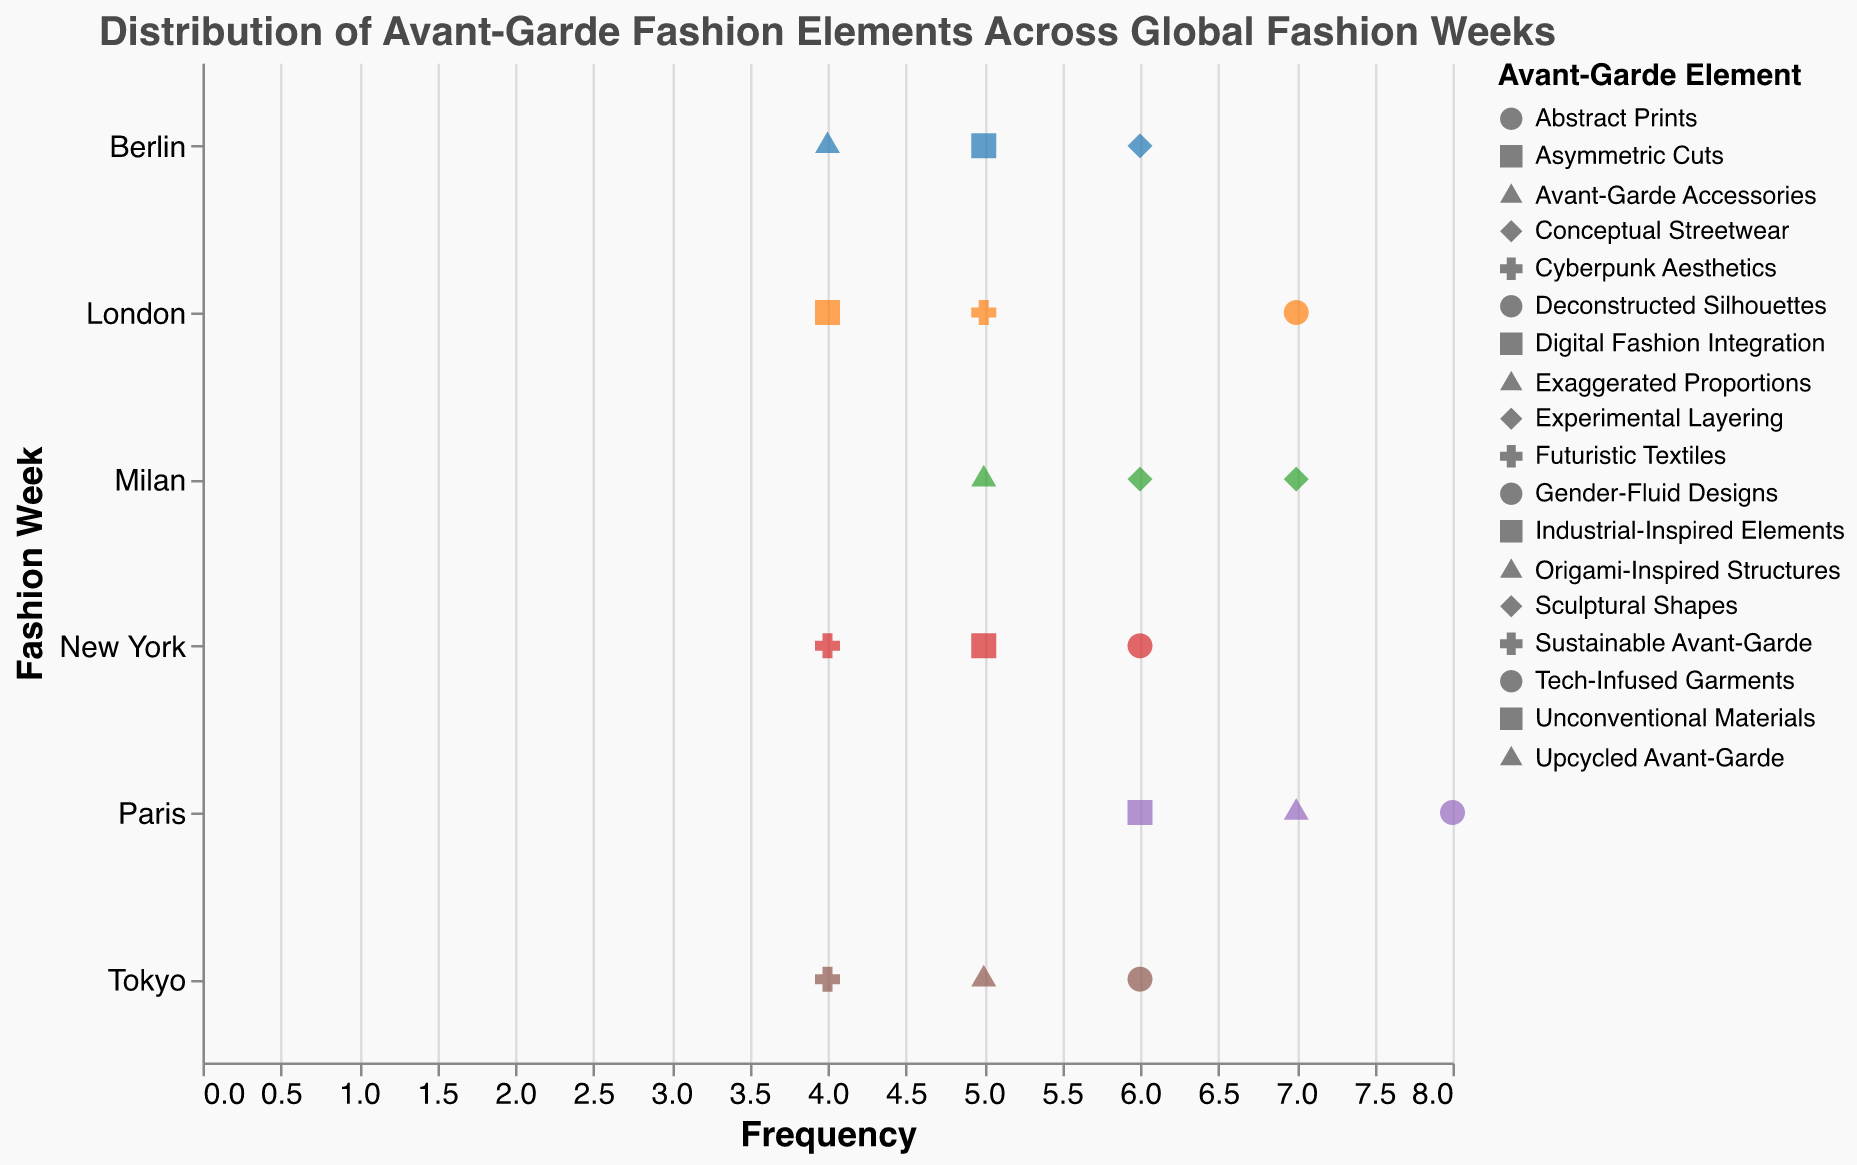What is the title of the plot? The title is located at the top of the plot and summarizes the visual's purpose. It reads, "Distribution of Avant-Garde Fashion Elements Across Global Fashion Weeks."
Answer: Distribution of Avant-Garde Fashion Elements Across Global Fashion Weeks Which fashion week has the highest frequency for the element "Deconstructed Silhouettes"? Look for the data point representing "Deconstructed Silhouettes" and identify the fashion week. The highest frequency for this element is found in Paris.
Answer: Paris What is the shape representing "Experimental Layering"? Check the shape legend for the specific Nominal types and look for "Experimental Layering". The corresponding shape is a triangle.
Answer: Triangle How many data points are present for Milan? Count the visual points along the y-axis where "Fashion Week" is listed as "Milan". Milan has three data points.
Answer: 3 Which fashion week has the most diversity in avant-garde elements? Identify the fashion week with the most unique shapes (elements). Paris, New York, Milan, London, Tokyo, and Berlin each have a maximum of 3 unique elements, indicating they all share the same diversity level.
Answer: Tied between Paris, New York, Milan, London, Tokyo, Berlin What is the difference in frequency of "Sculptural Shapes" between Milan and New York? Locate the frequencies for "Sculptural Shapes" in both fashion weeks. Milan has a frequency of 7 while New York does not have this element listed, so the difference is 7.
Answer: 7 Which fashion week has the lowest frequency of any avant-garde element? Look for the smallest value on the x-axis for each fashion week. The minimum frequency listed is 4, found in New York, London, Tokyo, and Berlin.
Answer: Tied among New York, London, Tokyo, Berlin Which element has the highest average frequency across all fashion weeks? Calculate the mean frequencies for each element across all data points. "Deconstructed Silhouettes" (8), "Abstract Prints" (6), "Gender-Fluid Designs" (7), and "Sculptural Shapes" (7) appear frequently, leading to high averages, but "Deconstructed Silhouettes" alone has the highest average at 8.
Answer: Deconstructed Silhouettes Are there any elements that appear in only one fashion week? Analyze the elements listed and identify any that are unique to a single fashion week. Elements such as "Deconstructed Silhouettes", "Asymmetric Cuts" and "Exaggerated Proportions" emerge solely in Paris.
Answer: Deconstructed Silhouettes, Asymmetric Cuts, Exaggerated Proportions 